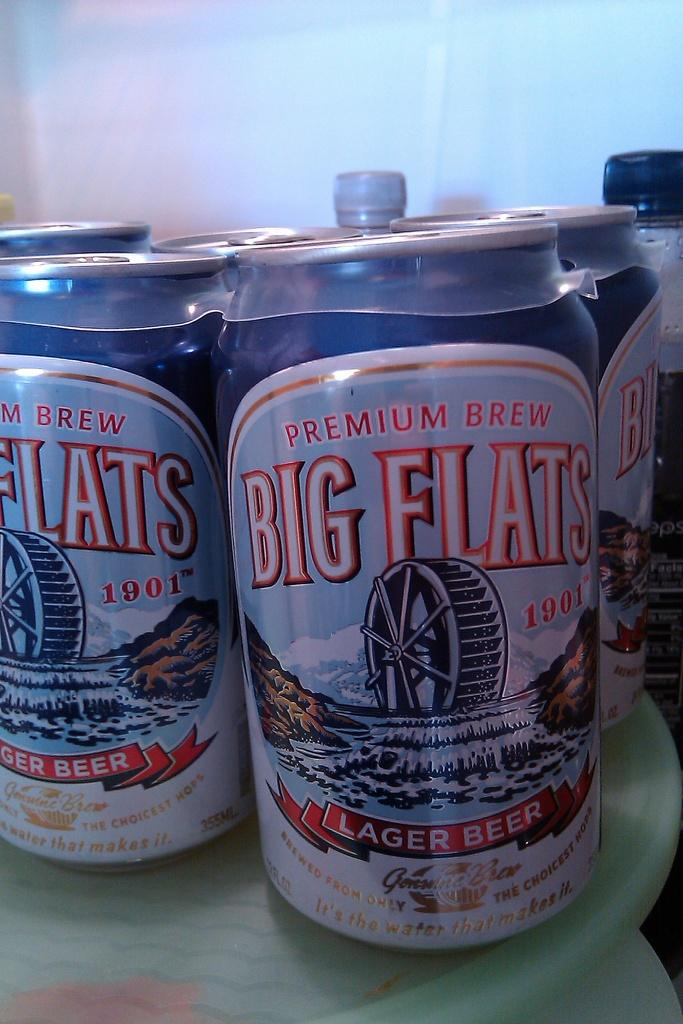<image>
Render a clear and concise summary of the photo. A six-pack of Big Flats lager in a cooler with other drinks. 